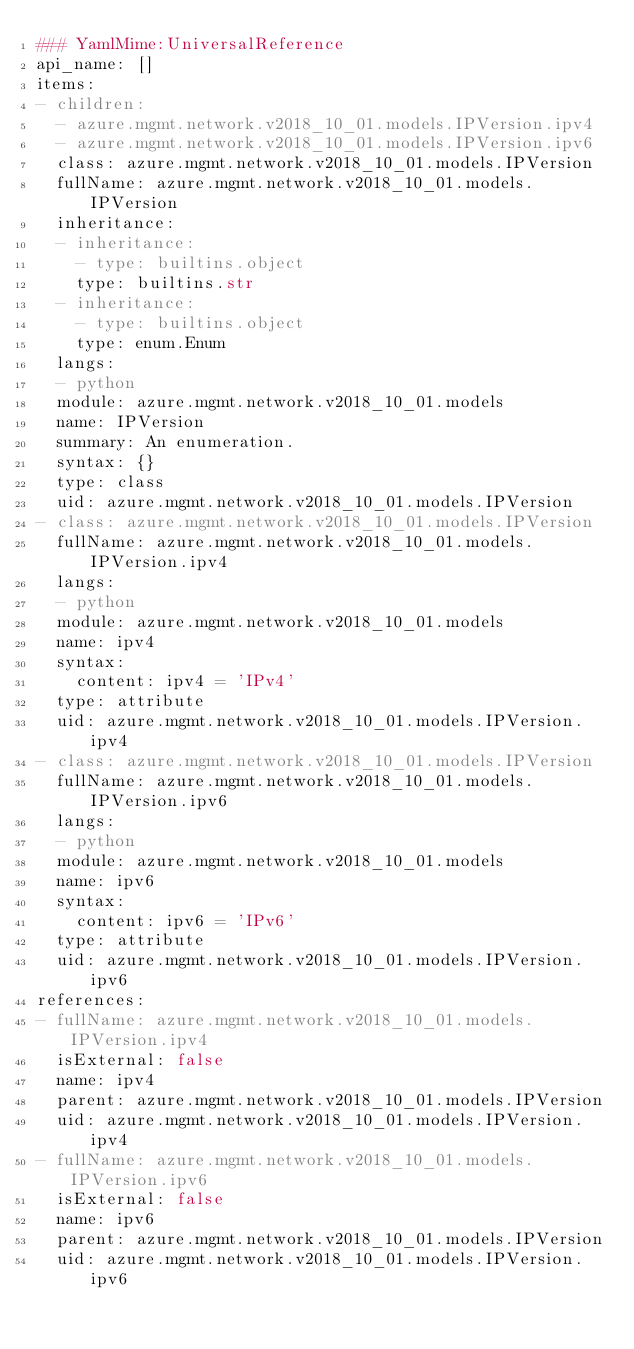Convert code to text. <code><loc_0><loc_0><loc_500><loc_500><_YAML_>### YamlMime:UniversalReference
api_name: []
items:
- children:
  - azure.mgmt.network.v2018_10_01.models.IPVersion.ipv4
  - azure.mgmt.network.v2018_10_01.models.IPVersion.ipv6
  class: azure.mgmt.network.v2018_10_01.models.IPVersion
  fullName: azure.mgmt.network.v2018_10_01.models.IPVersion
  inheritance:
  - inheritance:
    - type: builtins.object
    type: builtins.str
  - inheritance:
    - type: builtins.object
    type: enum.Enum
  langs:
  - python
  module: azure.mgmt.network.v2018_10_01.models
  name: IPVersion
  summary: An enumeration.
  syntax: {}
  type: class
  uid: azure.mgmt.network.v2018_10_01.models.IPVersion
- class: azure.mgmt.network.v2018_10_01.models.IPVersion
  fullName: azure.mgmt.network.v2018_10_01.models.IPVersion.ipv4
  langs:
  - python
  module: azure.mgmt.network.v2018_10_01.models
  name: ipv4
  syntax:
    content: ipv4 = 'IPv4'
  type: attribute
  uid: azure.mgmt.network.v2018_10_01.models.IPVersion.ipv4
- class: azure.mgmt.network.v2018_10_01.models.IPVersion
  fullName: azure.mgmt.network.v2018_10_01.models.IPVersion.ipv6
  langs:
  - python
  module: azure.mgmt.network.v2018_10_01.models
  name: ipv6
  syntax:
    content: ipv6 = 'IPv6'
  type: attribute
  uid: azure.mgmt.network.v2018_10_01.models.IPVersion.ipv6
references:
- fullName: azure.mgmt.network.v2018_10_01.models.IPVersion.ipv4
  isExternal: false
  name: ipv4
  parent: azure.mgmt.network.v2018_10_01.models.IPVersion
  uid: azure.mgmt.network.v2018_10_01.models.IPVersion.ipv4
- fullName: azure.mgmt.network.v2018_10_01.models.IPVersion.ipv6
  isExternal: false
  name: ipv6
  parent: azure.mgmt.network.v2018_10_01.models.IPVersion
  uid: azure.mgmt.network.v2018_10_01.models.IPVersion.ipv6
</code> 